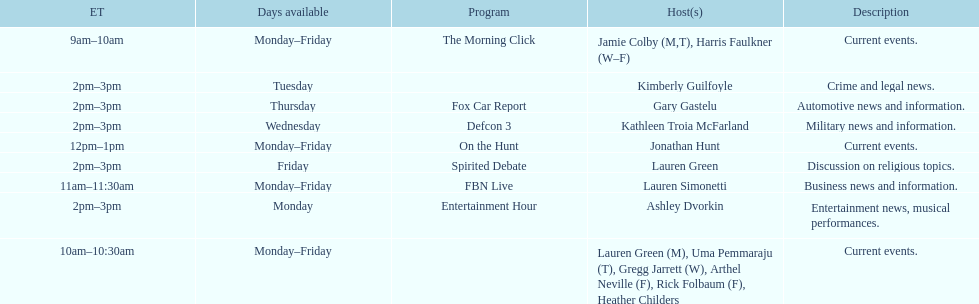What is the first show to play on monday mornings? The Morning Click. 